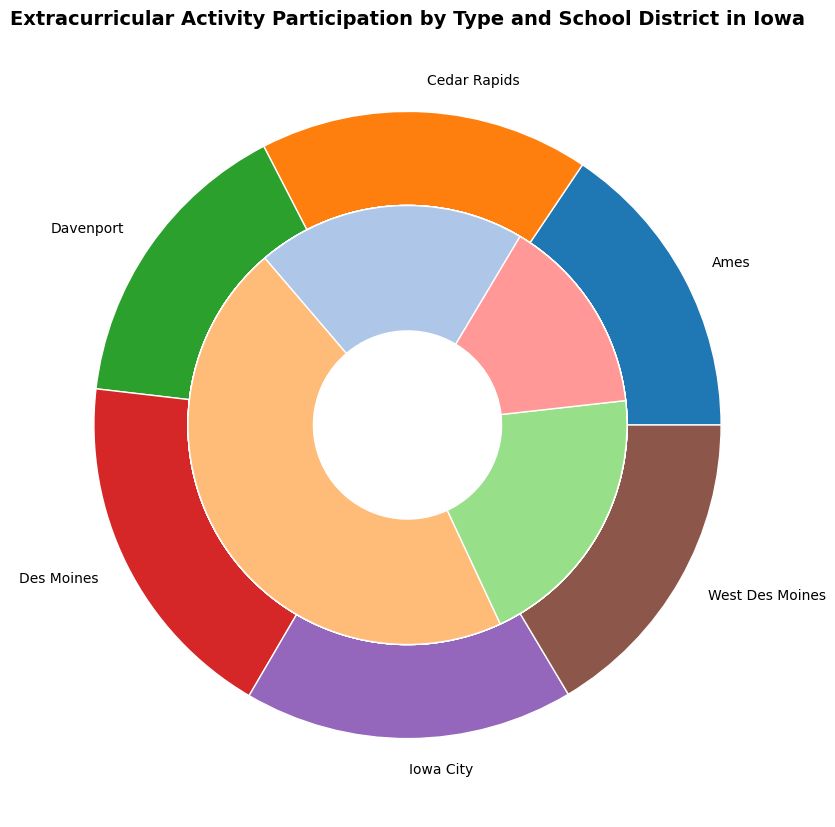What school district has the highest overall participation in extracurricular activities? Look at the outer pie chart slices. The slice for Des Moines is the largest, therefore indicating the highest overall participation.
Answer: Des Moines Which extracurricular type has the highest participation in Cedar Rapids? Refer to the inner pie slices specifically for Cedar Rapids. The largest inner slice for Cedar Rapids belongs to the Athletics category.
Answer: Athletics How much greater is the number of students participating in Athletics in Des Moines compared to Ames? Look at the inner pie slices representing Athletics for both Des Moines and Ames. Des Moines has 290 participants, while Ames has 250. The difference is 290 - 250.
Answer: 40 Which school district has a lower total participation in Arts compared to Athletics? Compare the inner pie slices for Arts and Athletics for each district. All districts have a smaller Arts slice compared to Athletics, so all districts meet this criterion.
Answer: All districts What percentage of the total extracurricular participation in Iowa City is from Science and Technology? Calculate the proportion of the Science and Technology slice. The participation in Science and Technology is 95. The total participation in Iowa City is 125 + 275 + 105 + 95 = 600. So, the percentage is (95 / 600) * 100.
Answer: 15.83% Which school districts have an equal number of participants in Clubs? Compare the inner pie slices for Clubs. Ames and West Des Moines both have 115 participants in Clubs.
Answer: Ames and West Des Moines Between Ames and Cedar Rapids, which district has a higher participation in Science and Technology and by how much? Compare the inner slices for Science and Technology. Cedar Rapids has 90 participants while Ames has 80. The difference is 90 - 80.
Answer: Cedar Rapids by 10 What is the ratio of participants in Athletics to those in Clubs in Davenport? Look at the counts for Davenport. Athletics has 260 participants, and Clubs have 95. The ratio is 260 / 95.
Answer: 2.74 Which extracurricular type tends to have the smallest participation across all school districts? For each district, compare the smallest inner pie slices. Science and Technology generally have the smallest slices in each district.
Answer: Science and Technology How does participation in Arts in Iowa City compare to that in West Des Moines? Compare the inner slices for Arts between the two districts. Iowa City has 125 participants in Arts, and West Des Moines has 115. Therefore, Iowa City has more participants in Arts.
Answer: Iowa City has more by 10 